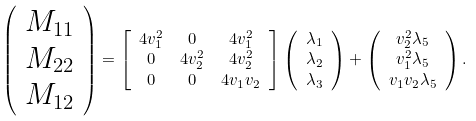Convert formula to latex. <formula><loc_0><loc_0><loc_500><loc_500>\left ( \begin{array} { c } M _ { 1 1 } \\ M _ { 2 2 } \\ M _ { 1 2 } \end{array} \right ) & = \left [ \begin{array} { c c c } 4 v _ { 1 } ^ { 2 } & 0 & 4 v _ { 1 } ^ { 2 } \\ 0 & 4 v _ { 2 } ^ { 2 } & 4 v _ { 2 } ^ { 2 } \\ 0 & 0 & 4 v _ { 1 } v _ { 2 } \end{array} \right ] \left ( \begin{array} { c } \lambda _ { 1 } \\ \lambda _ { 2 } \\ \lambda _ { 3 } \end{array} \right ) + \left ( \begin{array} { c } v _ { 2 } ^ { 2 } \lambda _ { 5 } \\ v _ { 1 } ^ { 2 } \lambda _ { 5 } \\ v _ { 1 } v _ { 2 } \lambda _ { 5 } \end{array} \right ) .</formula> 